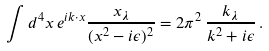<formula> <loc_0><loc_0><loc_500><loc_500>\int d ^ { 4 } x \, e ^ { i k \cdot x } \frac { x _ { \lambda } } { ( x ^ { 2 } - i \epsilon ) ^ { 2 } } = 2 \pi ^ { 2 } \, \frac { k _ { \lambda } } { k ^ { 2 } + i \epsilon } \, .</formula> 